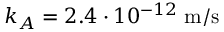Convert formula to latex. <formula><loc_0><loc_0><loc_500><loc_500>k _ { A } = 2 . 4 \cdot 1 0 ^ { - 1 2 } \, m / s</formula> 